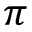<formula> <loc_0><loc_0><loc_500><loc_500>\pi</formula> 